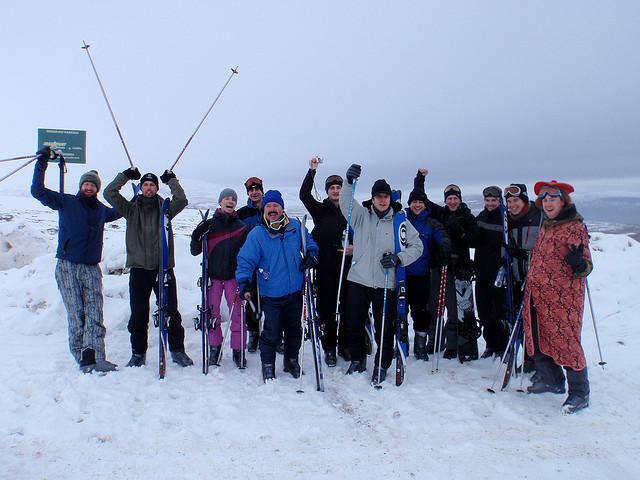Are there any women in the group?
Be succinct. Yes. What are the people going to do?
Answer briefly. Ski. Are these people celebrating an accomplishment?
Concise answer only. Yes. 